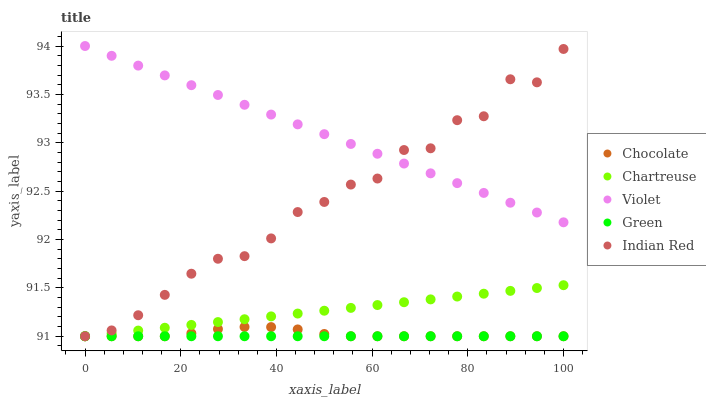Does Green have the minimum area under the curve?
Answer yes or no. Yes. Does Violet have the maximum area under the curve?
Answer yes or no. Yes. Does Violet have the minimum area under the curve?
Answer yes or no. No. Does Green have the maximum area under the curve?
Answer yes or no. No. Is Green the smoothest?
Answer yes or no. Yes. Is Indian Red the roughest?
Answer yes or no. Yes. Is Violet the smoothest?
Answer yes or no. No. Is Violet the roughest?
Answer yes or no. No. Does Chartreuse have the lowest value?
Answer yes or no. Yes. Does Violet have the lowest value?
Answer yes or no. No. Does Violet have the highest value?
Answer yes or no. Yes. Does Green have the highest value?
Answer yes or no. No. Is Chartreuse less than Violet?
Answer yes or no. Yes. Is Violet greater than Chartreuse?
Answer yes or no. Yes. Does Violet intersect Indian Red?
Answer yes or no. Yes. Is Violet less than Indian Red?
Answer yes or no. No. Is Violet greater than Indian Red?
Answer yes or no. No. Does Chartreuse intersect Violet?
Answer yes or no. No. 